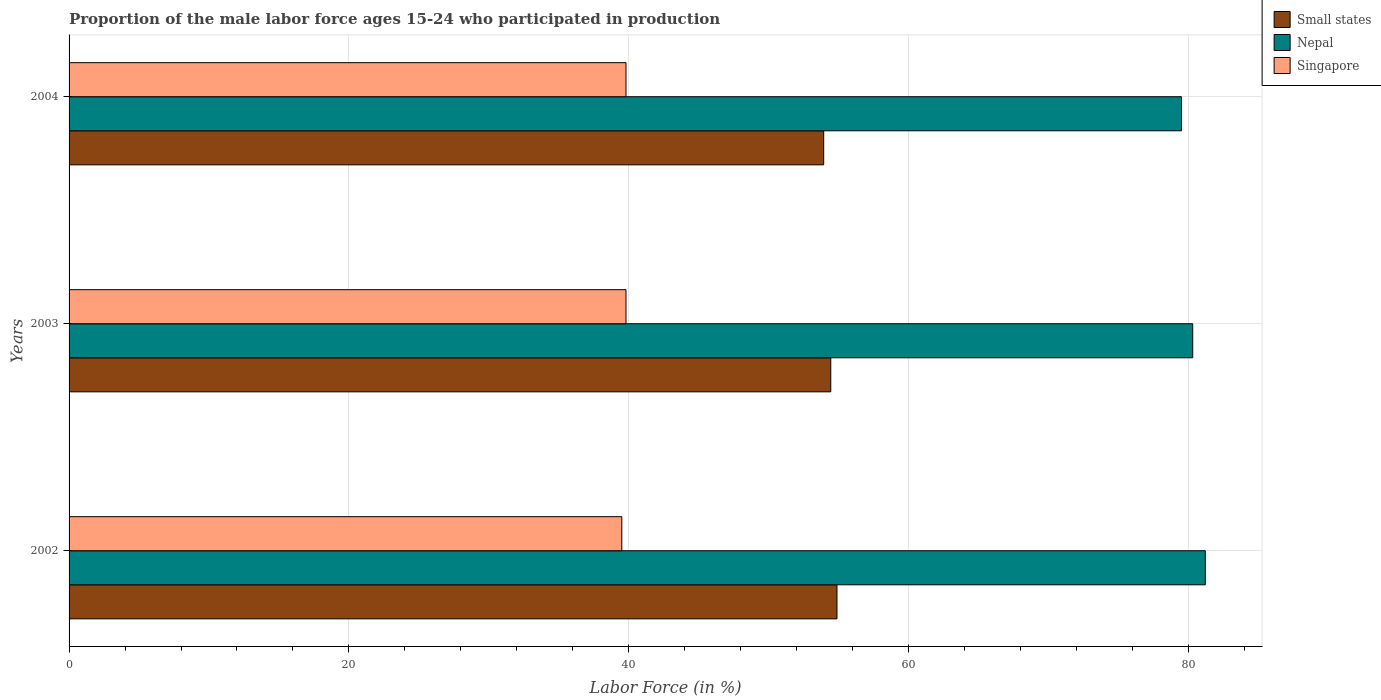How many different coloured bars are there?
Provide a succinct answer. 3. How many groups of bars are there?
Give a very brief answer. 3. Are the number of bars on each tick of the Y-axis equal?
Offer a terse response. Yes. How many bars are there on the 3rd tick from the top?
Your answer should be very brief. 3. How many bars are there on the 1st tick from the bottom?
Keep it short and to the point. 3. What is the label of the 3rd group of bars from the top?
Keep it short and to the point. 2002. What is the proportion of the male labor force who participated in production in Nepal in 2002?
Offer a very short reply. 81.2. Across all years, what is the maximum proportion of the male labor force who participated in production in Nepal?
Give a very brief answer. 81.2. Across all years, what is the minimum proportion of the male labor force who participated in production in Nepal?
Provide a short and direct response. 79.5. In which year was the proportion of the male labor force who participated in production in Nepal minimum?
Keep it short and to the point. 2004. What is the total proportion of the male labor force who participated in production in Nepal in the graph?
Your answer should be very brief. 241. What is the difference between the proportion of the male labor force who participated in production in Singapore in 2002 and that in 2003?
Offer a very short reply. -0.3. What is the difference between the proportion of the male labor force who participated in production in Singapore in 2004 and the proportion of the male labor force who participated in production in Small states in 2003?
Your answer should be compact. -14.63. What is the average proportion of the male labor force who participated in production in Singapore per year?
Offer a terse response. 39.7. In the year 2003, what is the difference between the proportion of the male labor force who participated in production in Nepal and proportion of the male labor force who participated in production in Small states?
Make the answer very short. 25.87. In how many years, is the proportion of the male labor force who participated in production in Singapore greater than 20 %?
Ensure brevity in your answer.  3. What is the ratio of the proportion of the male labor force who participated in production in Nepal in 2002 to that in 2003?
Your response must be concise. 1.01. Is the proportion of the male labor force who participated in production in Nepal in 2002 less than that in 2004?
Keep it short and to the point. No. What is the difference between the highest and the second highest proportion of the male labor force who participated in production in Nepal?
Offer a terse response. 0.9. What is the difference between the highest and the lowest proportion of the male labor force who participated in production in Singapore?
Provide a succinct answer. 0.3. In how many years, is the proportion of the male labor force who participated in production in Singapore greater than the average proportion of the male labor force who participated in production in Singapore taken over all years?
Offer a very short reply. 2. What does the 2nd bar from the top in 2004 represents?
Give a very brief answer. Nepal. What does the 3rd bar from the bottom in 2004 represents?
Make the answer very short. Singapore. Is it the case that in every year, the sum of the proportion of the male labor force who participated in production in Singapore and proportion of the male labor force who participated in production in Small states is greater than the proportion of the male labor force who participated in production in Nepal?
Your answer should be very brief. Yes. Are all the bars in the graph horizontal?
Provide a succinct answer. Yes. How many years are there in the graph?
Make the answer very short. 3. What is the difference between two consecutive major ticks on the X-axis?
Provide a succinct answer. 20. Are the values on the major ticks of X-axis written in scientific E-notation?
Keep it short and to the point. No. Where does the legend appear in the graph?
Offer a very short reply. Top right. What is the title of the graph?
Make the answer very short. Proportion of the male labor force ages 15-24 who participated in production. Does "Tuvalu" appear as one of the legend labels in the graph?
Offer a very short reply. No. What is the label or title of the X-axis?
Your answer should be very brief. Labor Force (in %). What is the Labor Force (in %) in Small states in 2002?
Offer a terse response. 54.88. What is the Labor Force (in %) of Nepal in 2002?
Ensure brevity in your answer.  81.2. What is the Labor Force (in %) of Singapore in 2002?
Your response must be concise. 39.5. What is the Labor Force (in %) in Small states in 2003?
Give a very brief answer. 54.43. What is the Labor Force (in %) in Nepal in 2003?
Your response must be concise. 80.3. What is the Labor Force (in %) in Singapore in 2003?
Provide a succinct answer. 39.8. What is the Labor Force (in %) in Small states in 2004?
Your answer should be compact. 53.93. What is the Labor Force (in %) in Nepal in 2004?
Provide a short and direct response. 79.5. What is the Labor Force (in %) in Singapore in 2004?
Keep it short and to the point. 39.8. Across all years, what is the maximum Labor Force (in %) of Small states?
Your response must be concise. 54.88. Across all years, what is the maximum Labor Force (in %) in Nepal?
Ensure brevity in your answer.  81.2. Across all years, what is the maximum Labor Force (in %) in Singapore?
Provide a succinct answer. 39.8. Across all years, what is the minimum Labor Force (in %) in Small states?
Provide a short and direct response. 53.93. Across all years, what is the minimum Labor Force (in %) of Nepal?
Offer a terse response. 79.5. Across all years, what is the minimum Labor Force (in %) of Singapore?
Ensure brevity in your answer.  39.5. What is the total Labor Force (in %) of Small states in the graph?
Your answer should be compact. 163.24. What is the total Labor Force (in %) in Nepal in the graph?
Your answer should be very brief. 241. What is the total Labor Force (in %) of Singapore in the graph?
Offer a very short reply. 119.1. What is the difference between the Labor Force (in %) of Small states in 2002 and that in 2003?
Offer a terse response. 0.44. What is the difference between the Labor Force (in %) in Nepal in 2002 and that in 2003?
Provide a short and direct response. 0.9. What is the difference between the Labor Force (in %) in Singapore in 2002 and that in 2003?
Provide a succinct answer. -0.3. What is the difference between the Labor Force (in %) in Small states in 2002 and that in 2004?
Your answer should be very brief. 0.95. What is the difference between the Labor Force (in %) of Small states in 2003 and that in 2004?
Ensure brevity in your answer.  0.51. What is the difference between the Labor Force (in %) of Nepal in 2003 and that in 2004?
Make the answer very short. 0.8. What is the difference between the Labor Force (in %) in Singapore in 2003 and that in 2004?
Provide a succinct answer. 0. What is the difference between the Labor Force (in %) of Small states in 2002 and the Labor Force (in %) of Nepal in 2003?
Provide a short and direct response. -25.42. What is the difference between the Labor Force (in %) of Small states in 2002 and the Labor Force (in %) of Singapore in 2003?
Make the answer very short. 15.08. What is the difference between the Labor Force (in %) of Nepal in 2002 and the Labor Force (in %) of Singapore in 2003?
Make the answer very short. 41.4. What is the difference between the Labor Force (in %) in Small states in 2002 and the Labor Force (in %) in Nepal in 2004?
Provide a succinct answer. -24.62. What is the difference between the Labor Force (in %) in Small states in 2002 and the Labor Force (in %) in Singapore in 2004?
Give a very brief answer. 15.08. What is the difference between the Labor Force (in %) of Nepal in 2002 and the Labor Force (in %) of Singapore in 2004?
Provide a short and direct response. 41.4. What is the difference between the Labor Force (in %) of Small states in 2003 and the Labor Force (in %) of Nepal in 2004?
Provide a succinct answer. -25.07. What is the difference between the Labor Force (in %) of Small states in 2003 and the Labor Force (in %) of Singapore in 2004?
Your answer should be very brief. 14.63. What is the difference between the Labor Force (in %) in Nepal in 2003 and the Labor Force (in %) in Singapore in 2004?
Ensure brevity in your answer.  40.5. What is the average Labor Force (in %) of Small states per year?
Your answer should be compact. 54.41. What is the average Labor Force (in %) in Nepal per year?
Your answer should be compact. 80.33. What is the average Labor Force (in %) of Singapore per year?
Your answer should be very brief. 39.7. In the year 2002, what is the difference between the Labor Force (in %) in Small states and Labor Force (in %) in Nepal?
Your answer should be very brief. -26.32. In the year 2002, what is the difference between the Labor Force (in %) in Small states and Labor Force (in %) in Singapore?
Keep it short and to the point. 15.38. In the year 2002, what is the difference between the Labor Force (in %) in Nepal and Labor Force (in %) in Singapore?
Your answer should be very brief. 41.7. In the year 2003, what is the difference between the Labor Force (in %) in Small states and Labor Force (in %) in Nepal?
Make the answer very short. -25.87. In the year 2003, what is the difference between the Labor Force (in %) in Small states and Labor Force (in %) in Singapore?
Ensure brevity in your answer.  14.63. In the year 2003, what is the difference between the Labor Force (in %) of Nepal and Labor Force (in %) of Singapore?
Make the answer very short. 40.5. In the year 2004, what is the difference between the Labor Force (in %) of Small states and Labor Force (in %) of Nepal?
Provide a short and direct response. -25.57. In the year 2004, what is the difference between the Labor Force (in %) of Small states and Labor Force (in %) of Singapore?
Keep it short and to the point. 14.13. In the year 2004, what is the difference between the Labor Force (in %) in Nepal and Labor Force (in %) in Singapore?
Offer a terse response. 39.7. What is the ratio of the Labor Force (in %) of Small states in 2002 to that in 2003?
Offer a terse response. 1.01. What is the ratio of the Labor Force (in %) in Nepal in 2002 to that in 2003?
Your answer should be compact. 1.01. What is the ratio of the Labor Force (in %) in Singapore in 2002 to that in 2003?
Give a very brief answer. 0.99. What is the ratio of the Labor Force (in %) of Small states in 2002 to that in 2004?
Offer a terse response. 1.02. What is the ratio of the Labor Force (in %) of Nepal in 2002 to that in 2004?
Ensure brevity in your answer.  1.02. What is the ratio of the Labor Force (in %) of Small states in 2003 to that in 2004?
Provide a short and direct response. 1.01. What is the ratio of the Labor Force (in %) of Nepal in 2003 to that in 2004?
Provide a succinct answer. 1.01. What is the difference between the highest and the second highest Labor Force (in %) of Small states?
Your response must be concise. 0.44. What is the difference between the highest and the second highest Labor Force (in %) of Nepal?
Ensure brevity in your answer.  0.9. What is the difference between the highest and the second highest Labor Force (in %) of Singapore?
Make the answer very short. 0. What is the difference between the highest and the lowest Labor Force (in %) of Small states?
Your answer should be very brief. 0.95. 